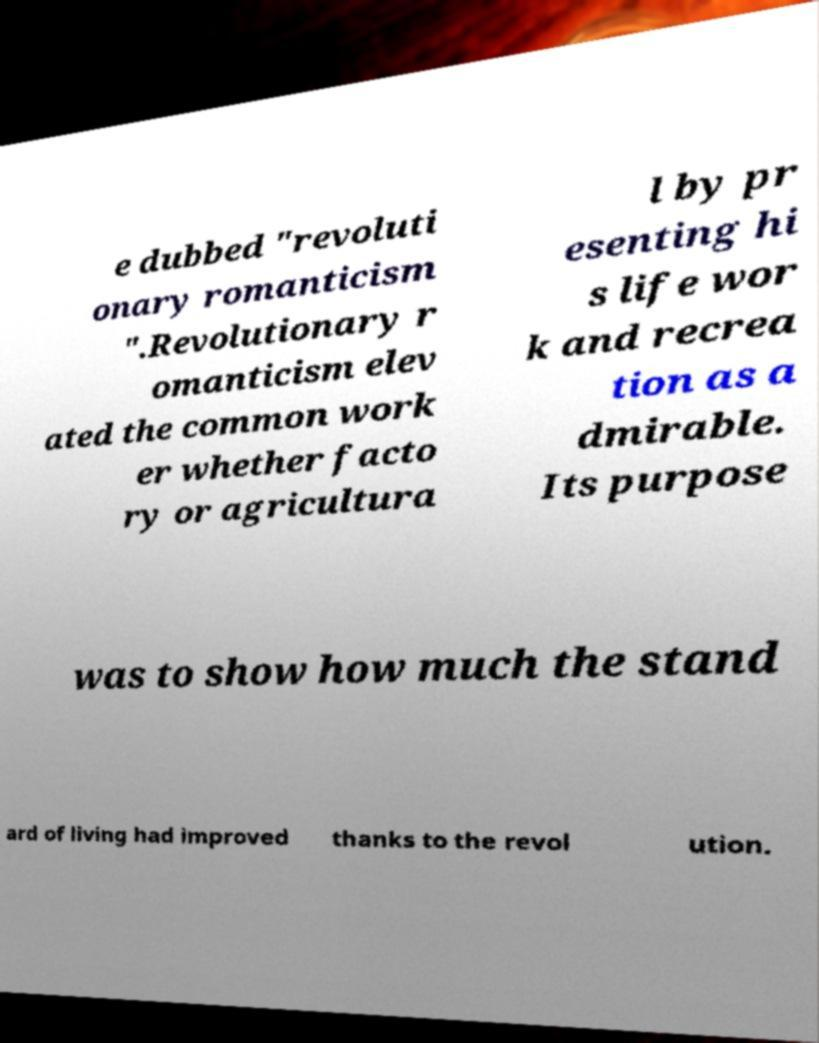Can you read and provide the text displayed in the image?This photo seems to have some interesting text. Can you extract and type it out for me? e dubbed "revoluti onary romanticism ".Revolutionary r omanticism elev ated the common work er whether facto ry or agricultura l by pr esenting hi s life wor k and recrea tion as a dmirable. Its purpose was to show how much the stand ard of living had improved thanks to the revol ution. 